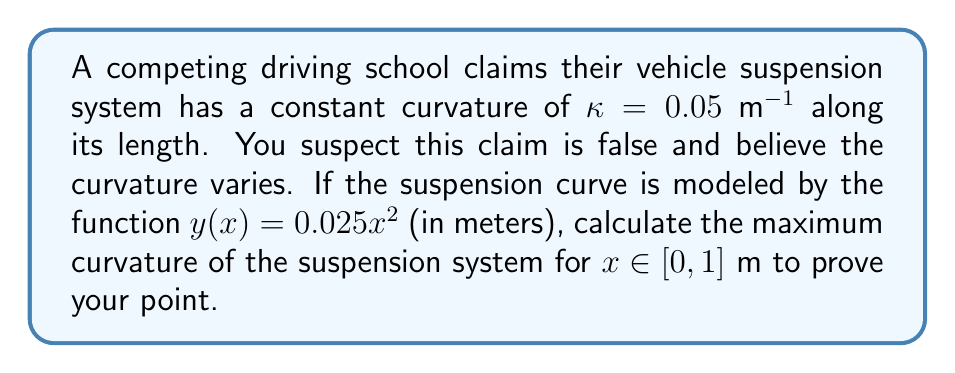Could you help me with this problem? To analyze the curvature of the suspension system, we'll follow these steps:

1) The general formula for curvature of a function $y(x)$ is:

   $$\kappa(x) = \frac{|y''(x)|}{(1 + (y'(x))^2)^{3/2}}$$

2) First, we need to find $y'(x)$ and $y''(x)$:
   
   $y(x) = 0.025x^2$
   $y'(x) = 0.05x$
   $y''(x) = 0.05$

3) Now, let's substitute these into the curvature formula:

   $$\kappa(x) = \frac{|0.05|}{(1 + (0.05x)^2)^{3/2}}$$

4) Simplify:

   $$\kappa(x) = \frac{0.05}{(1 + 0.0025x^2)^{3/2}}$$

5) To find the maximum curvature, we need to find the minimum value of the denominator for $x \in [0, 1]$. The denominator is smallest when $x = 0$.

6) Therefore, the maximum curvature occurs at $x = 0$:

   $$\kappa_{max} = \kappa(0) = \frac{0.05}{(1 + 0)^{3/2}} = 0.05\text{ m}^{-1}$$

This shows that the maximum curvature is indeed 0.05 m^(-1), but it only occurs at one point (x = 0). The curvature decreases as x increases, proving that the competing school's claim of constant curvature is false.
Answer: $0.05\text{ m}^{-1}$ 